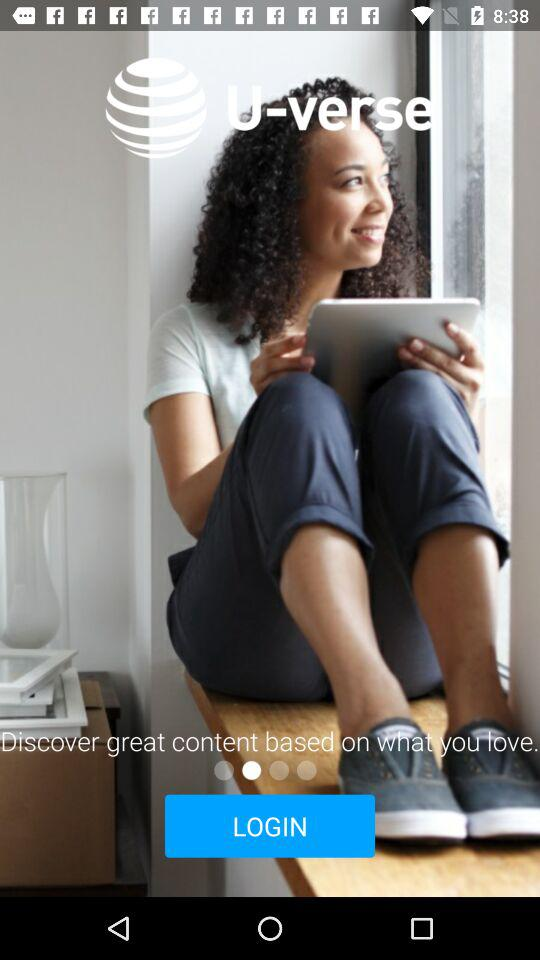Who is "U-verse" powered by?
When the provided information is insufficient, respond with <no answer>. <no answer> 